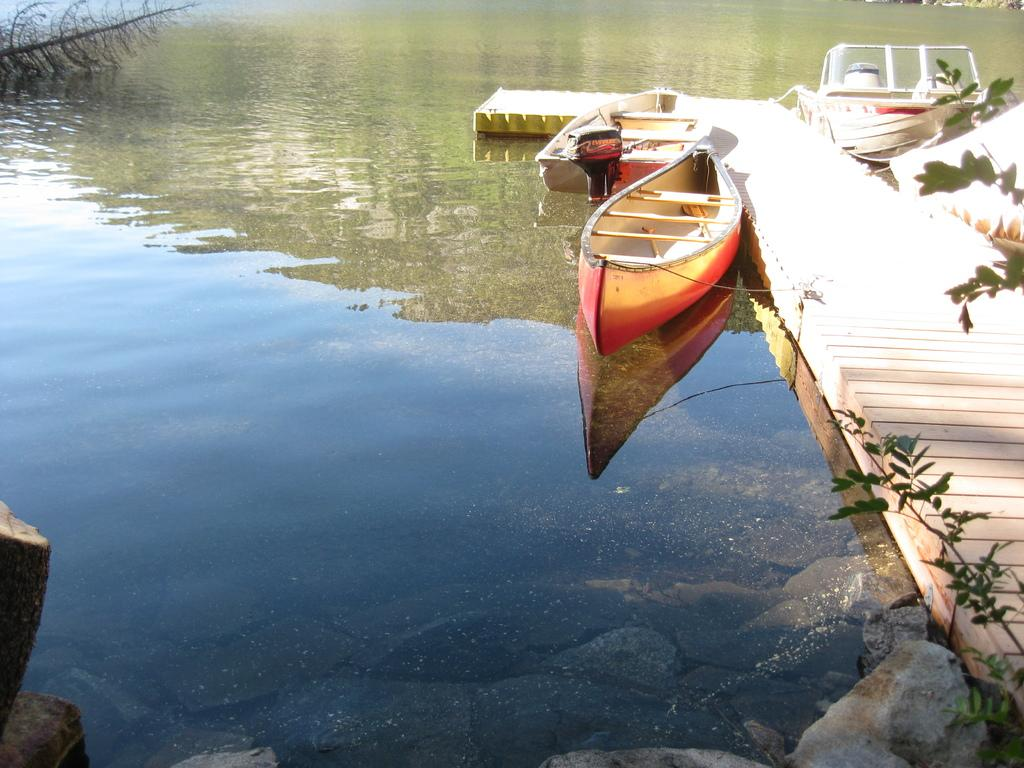What is present on the river in the image? There are boats on the river in the image. What type of structure is visible across the river? There is a wooden walking path across the river in the image. What natural elements can be seen near the river? Rocks and plants are visible near the river in the image. What is the purpose of the hose near the river in the image? There is no hose present in the image. How many spiders can be seen on the wooden walking path in the image? There are no spiders visible in the image. 